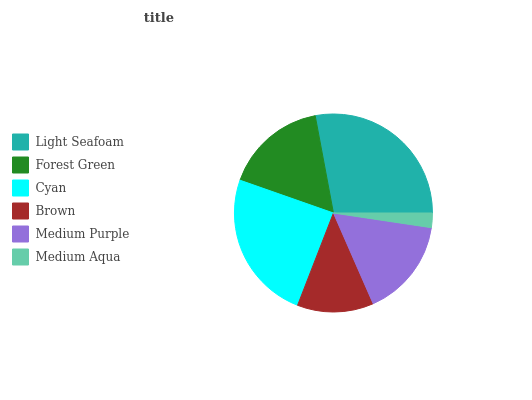Is Medium Aqua the minimum?
Answer yes or no. Yes. Is Light Seafoam the maximum?
Answer yes or no. Yes. Is Forest Green the minimum?
Answer yes or no. No. Is Forest Green the maximum?
Answer yes or no. No. Is Light Seafoam greater than Forest Green?
Answer yes or no. Yes. Is Forest Green less than Light Seafoam?
Answer yes or no. Yes. Is Forest Green greater than Light Seafoam?
Answer yes or no. No. Is Light Seafoam less than Forest Green?
Answer yes or no. No. Is Forest Green the high median?
Answer yes or no. Yes. Is Medium Purple the low median?
Answer yes or no. Yes. Is Light Seafoam the high median?
Answer yes or no. No. Is Medium Aqua the low median?
Answer yes or no. No. 